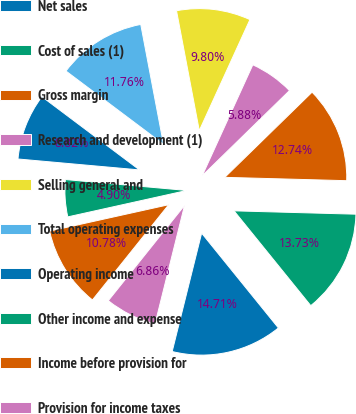<chart> <loc_0><loc_0><loc_500><loc_500><pie_chart><fcel>Net sales<fcel>Cost of sales (1)<fcel>Gross margin<fcel>Research and development (1)<fcel>Selling general and<fcel>Total operating expenses<fcel>Operating income<fcel>Other income and expense<fcel>Income before provision for<fcel>Provision for income taxes<nl><fcel>14.71%<fcel>13.73%<fcel>12.74%<fcel>5.88%<fcel>9.8%<fcel>11.76%<fcel>8.82%<fcel>4.9%<fcel>10.78%<fcel>6.86%<nl></chart> 